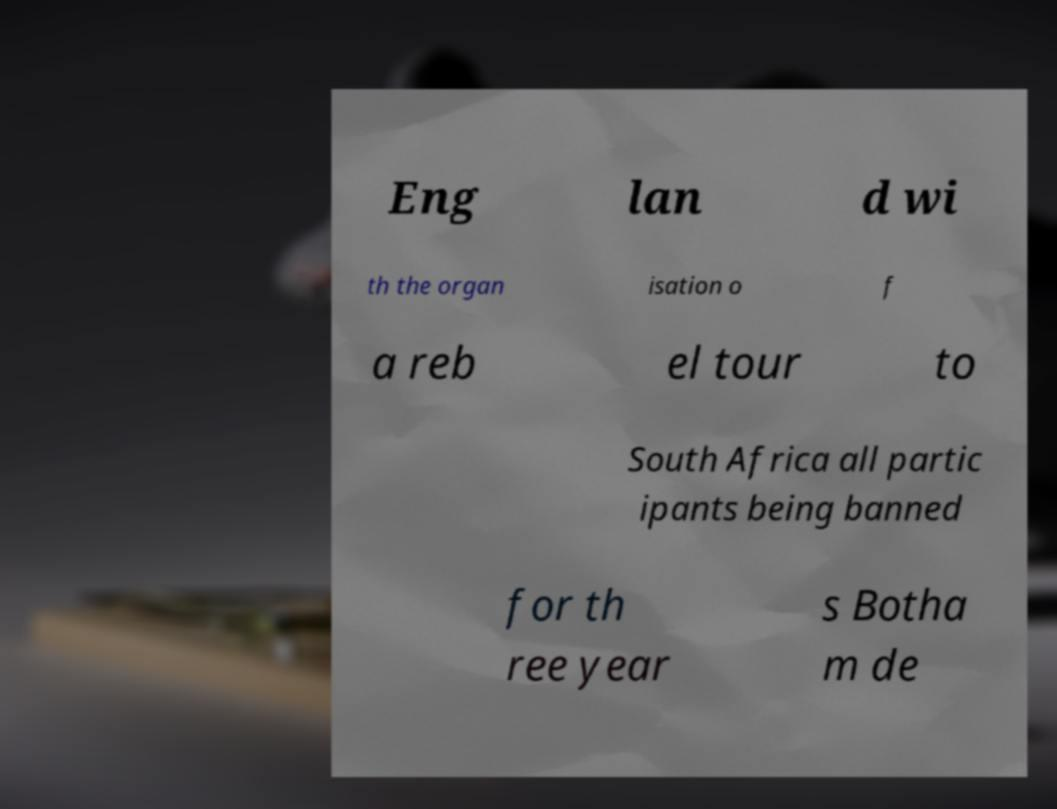Please read and relay the text visible in this image. What does it say? Eng lan d wi th the organ isation o f a reb el tour to South Africa all partic ipants being banned for th ree year s Botha m de 